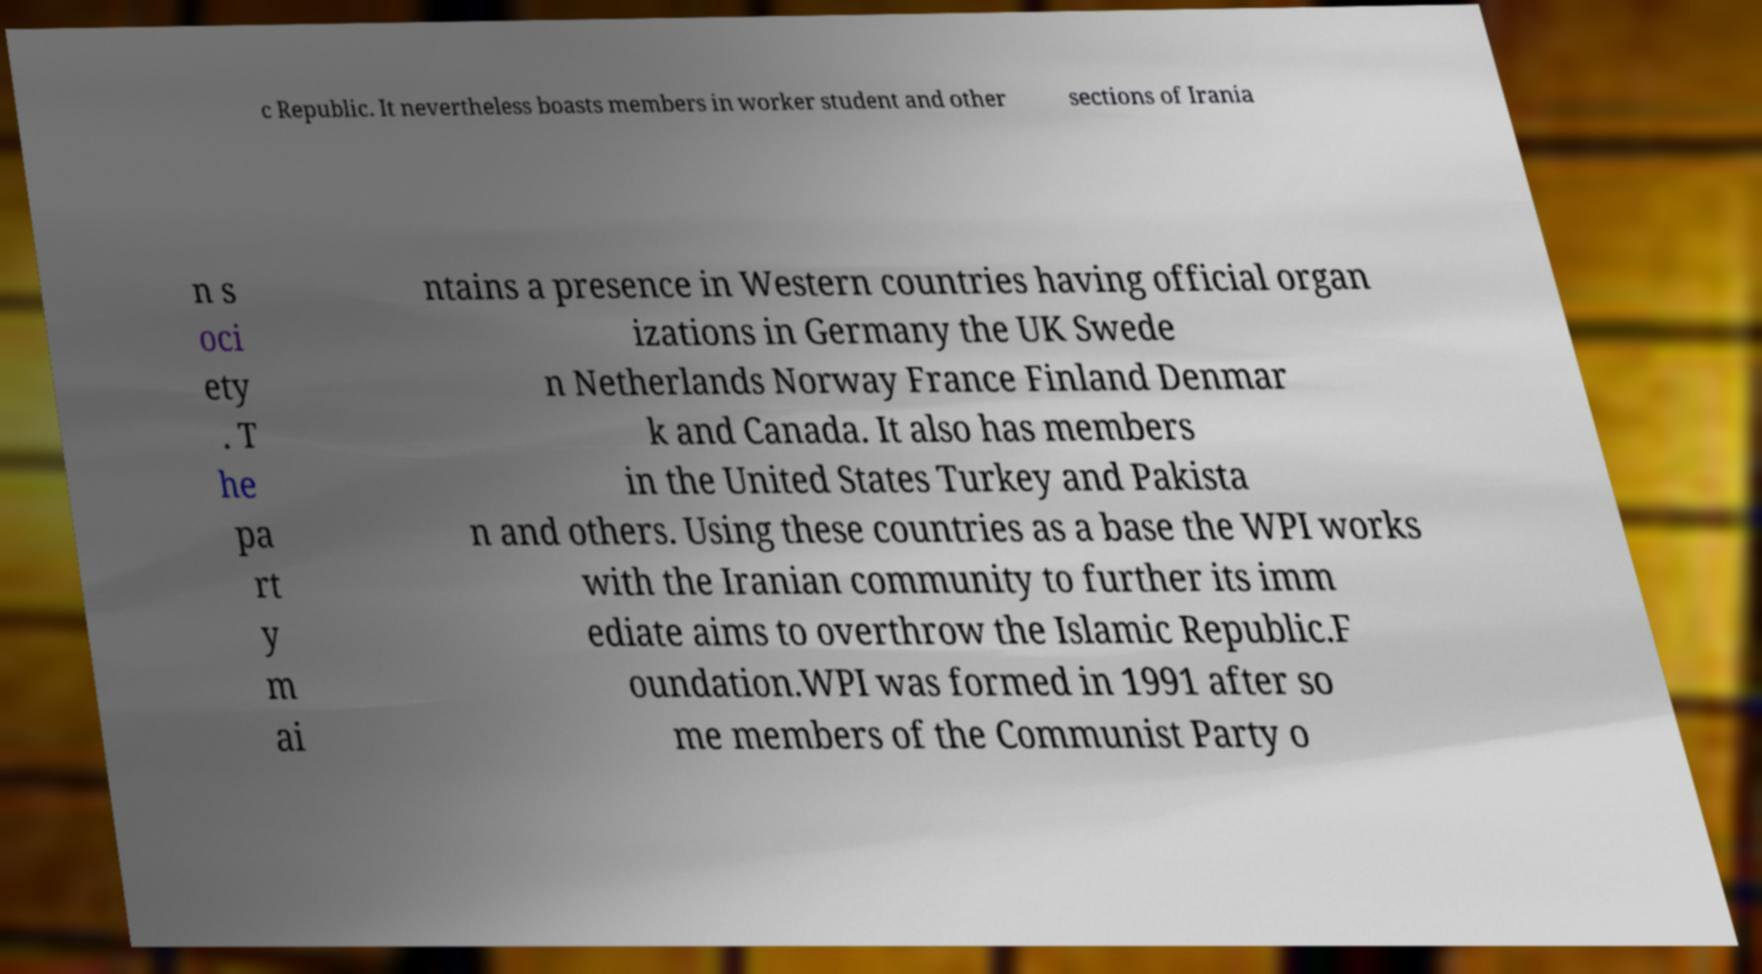For documentation purposes, I need the text within this image transcribed. Could you provide that? c Republic. It nevertheless boasts members in worker student and other sections of Irania n s oci ety . T he pa rt y m ai ntains a presence in Western countries having official organ izations in Germany the UK Swede n Netherlands Norway France Finland Denmar k and Canada. It also has members in the United States Turkey and Pakista n and others. Using these countries as a base the WPI works with the Iranian community to further its imm ediate aims to overthrow the Islamic Republic.F oundation.WPI was formed in 1991 after so me members of the Communist Party o 